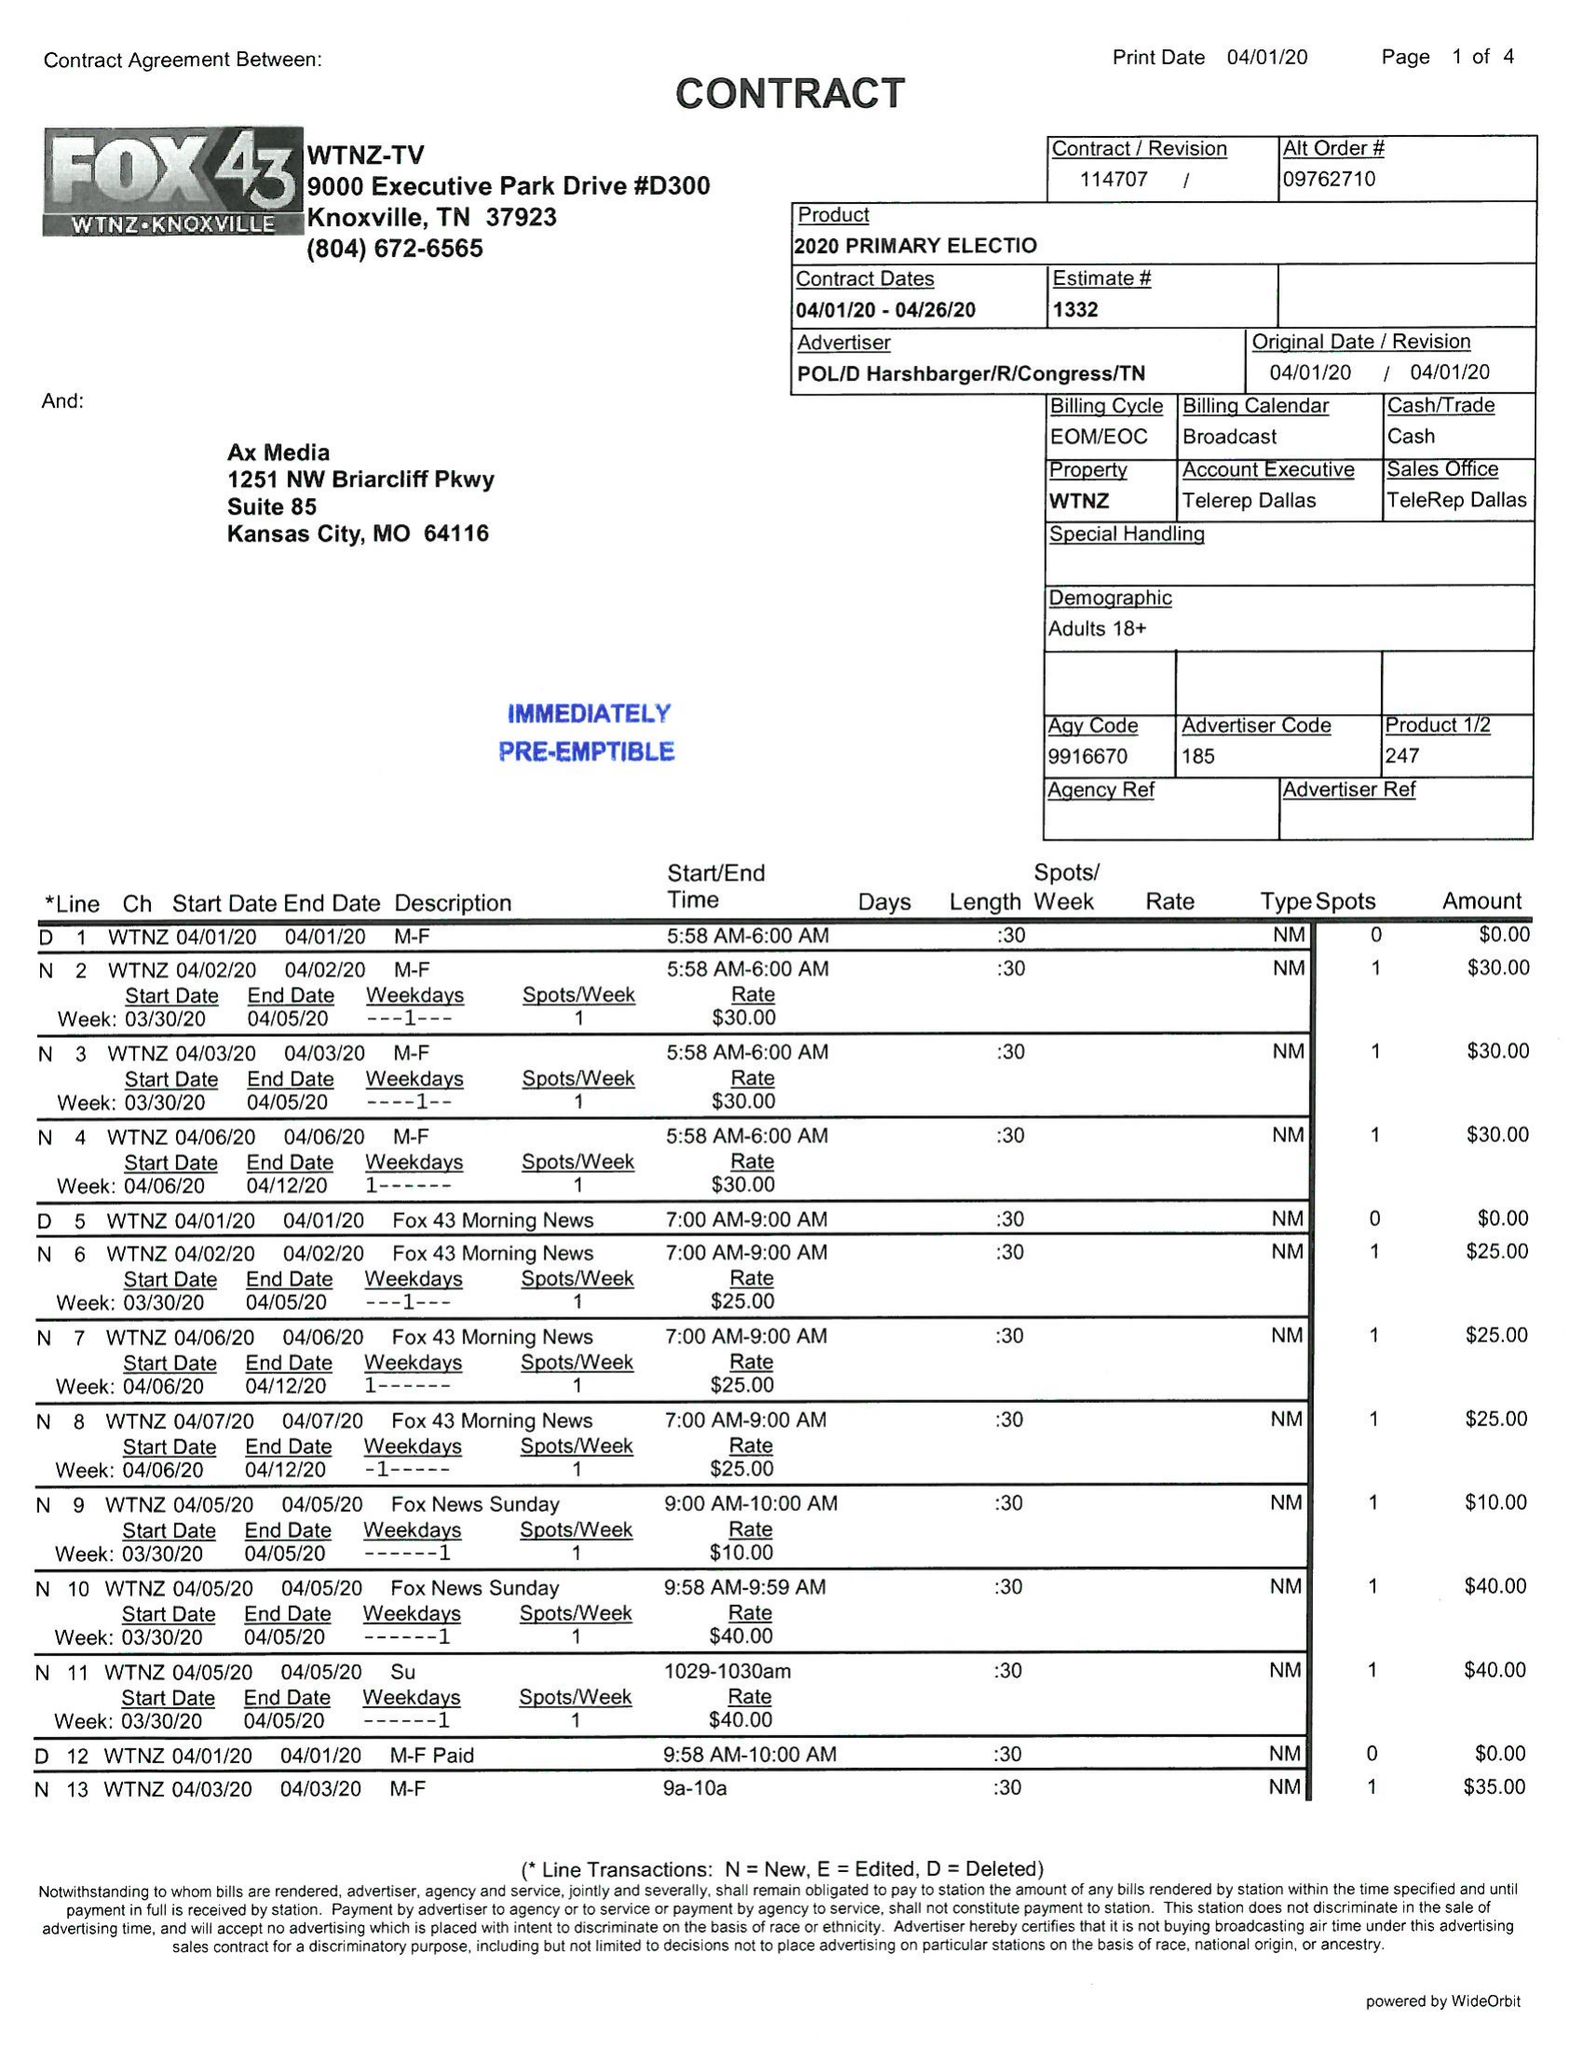What is the value for the advertiser?
Answer the question using a single word or phrase. POL/DHARSHBARGER/R/CONGRESS/TN 